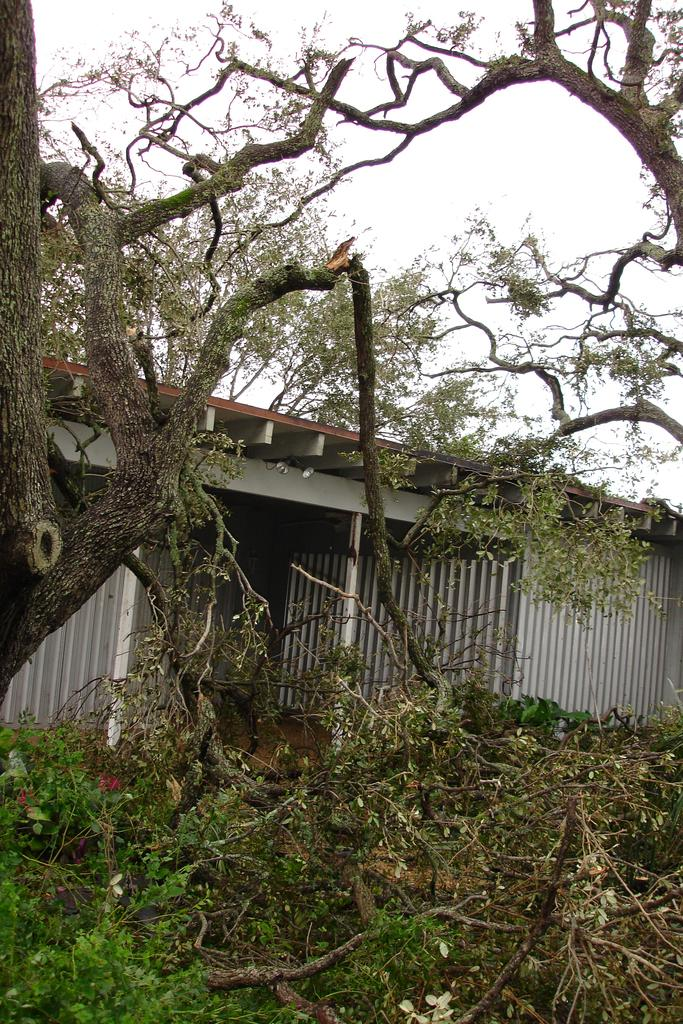What type of vegetation is present on the ground in the image? There are trees and plants on the ground in the image. What structure is located behind the trees and plants? There is a house behind the trees and plants. What is visible at the top of the image? The sky is visible at the top of the image. What type of seat can be seen in the image? There is no seat present in the image. What type of linen is draped over the trees in the image? There is no linen draped over the trees in the image. 